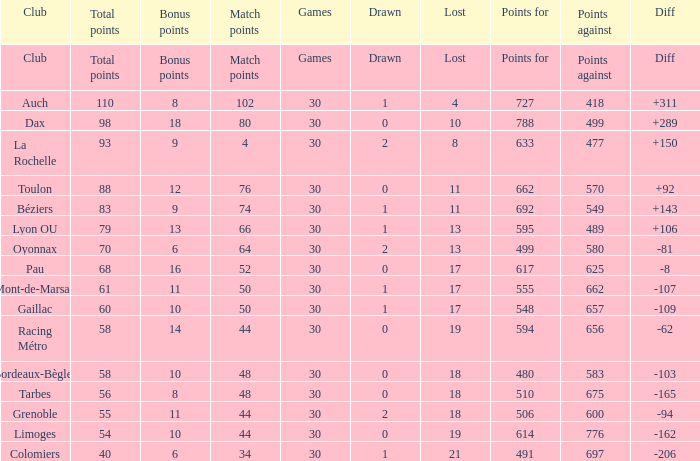What is the importance of match points when the points achieved is 570? 76.0. 